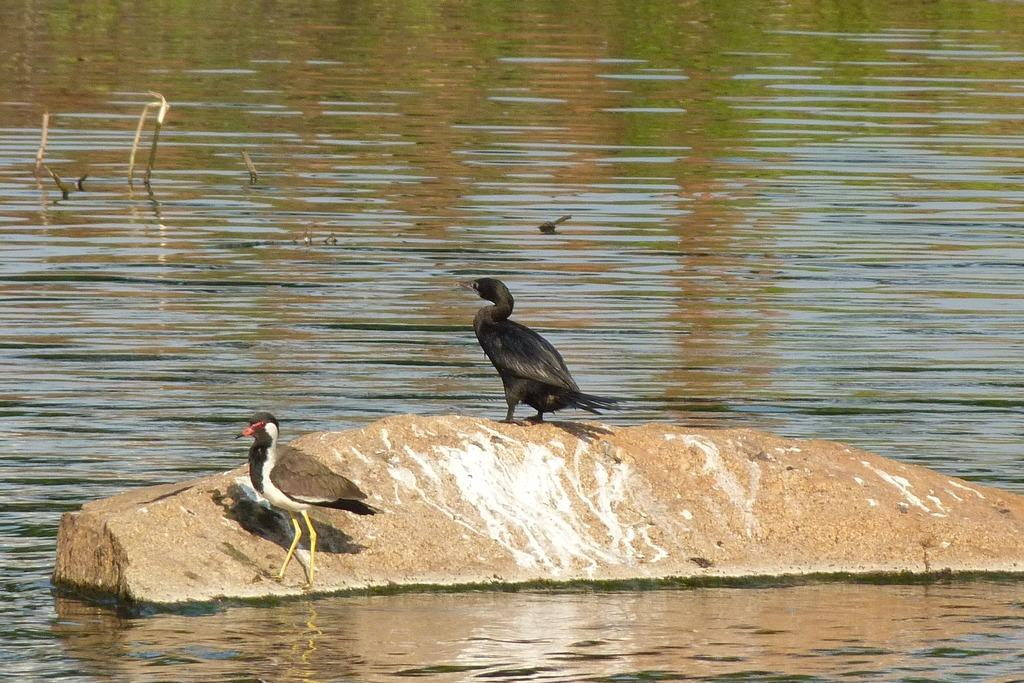What is the primary element in the image? There is water in the image. What is located within the water? A rock is present in the water. What can be seen on the rock? There are birds on the rock. What type of trick can be seen being performed by the cow in the image? There is no cow present in the image, so no trick can be observed. 